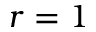<formula> <loc_0><loc_0><loc_500><loc_500>r = 1</formula> 